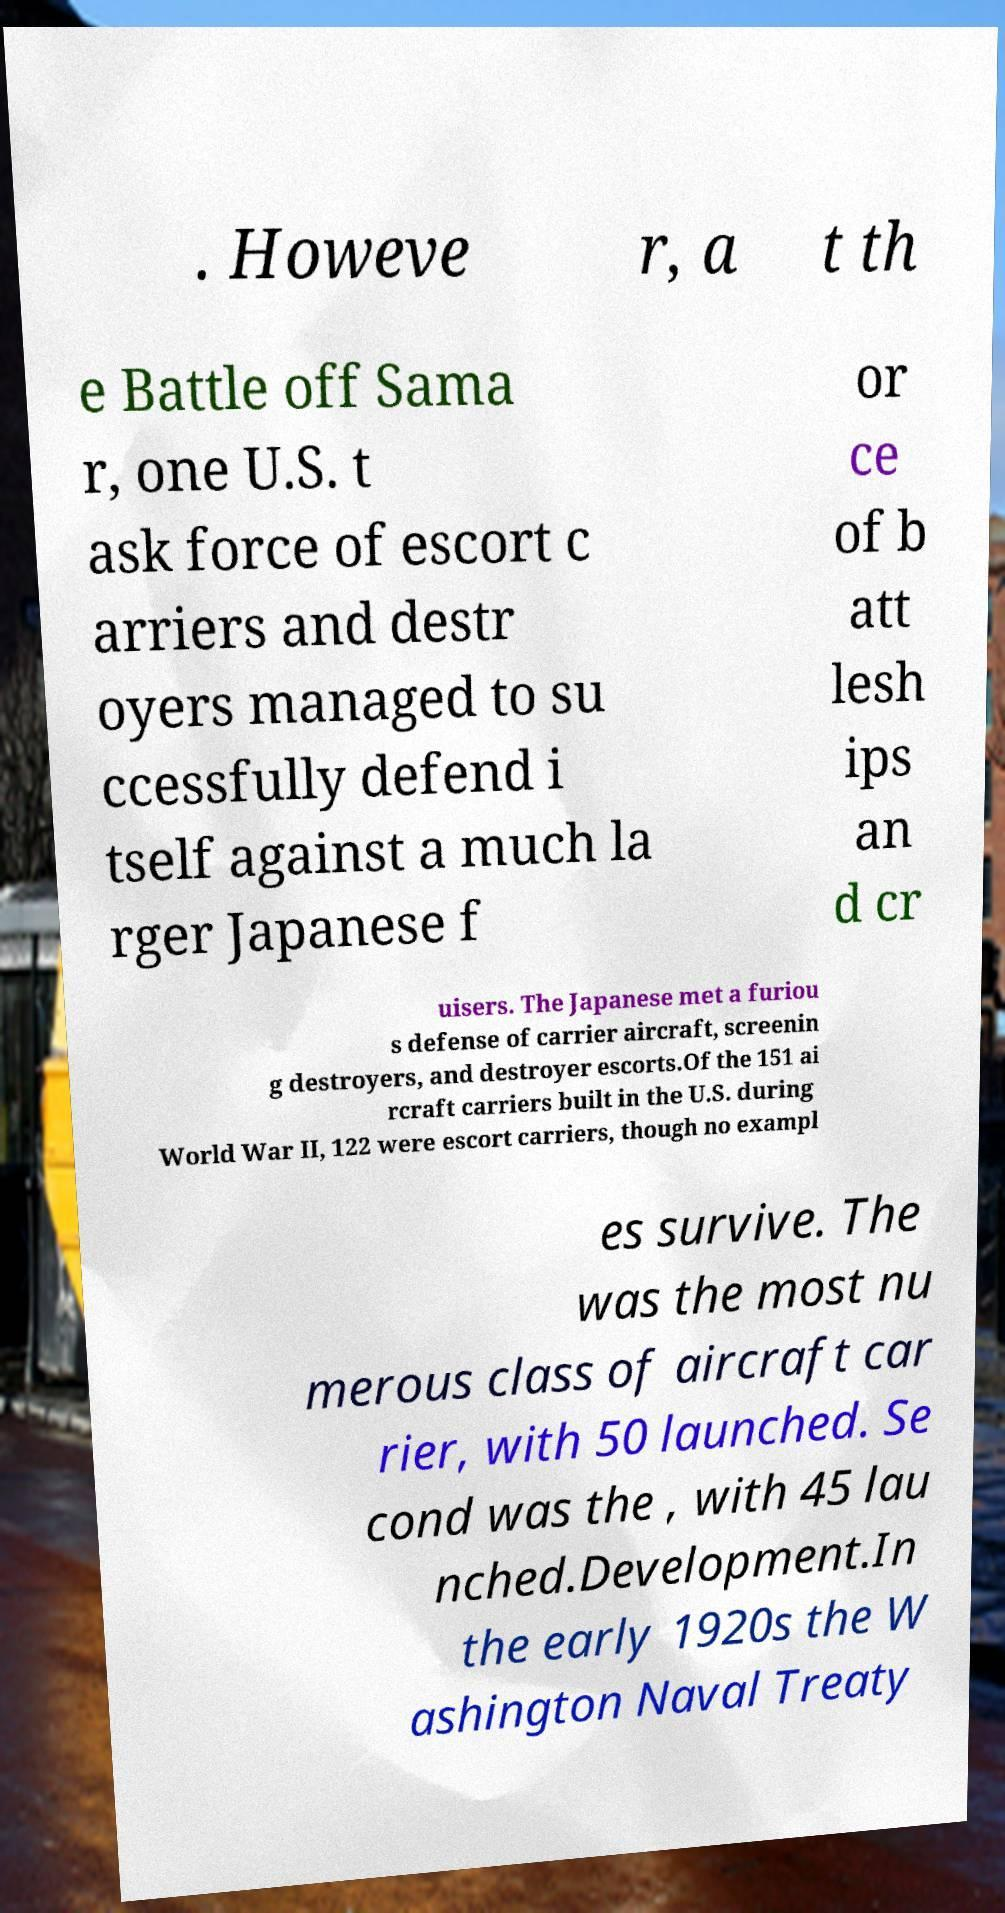I need the written content from this picture converted into text. Can you do that? . Howeve r, a t th e Battle off Sama r, one U.S. t ask force of escort c arriers and destr oyers managed to su ccessfully defend i tself against a much la rger Japanese f or ce of b att lesh ips an d cr uisers. The Japanese met a furiou s defense of carrier aircraft, screenin g destroyers, and destroyer escorts.Of the 151 ai rcraft carriers built in the U.S. during World War II, 122 were escort carriers, though no exampl es survive. The was the most nu merous class of aircraft car rier, with 50 launched. Se cond was the , with 45 lau nched.Development.In the early 1920s the W ashington Naval Treaty 